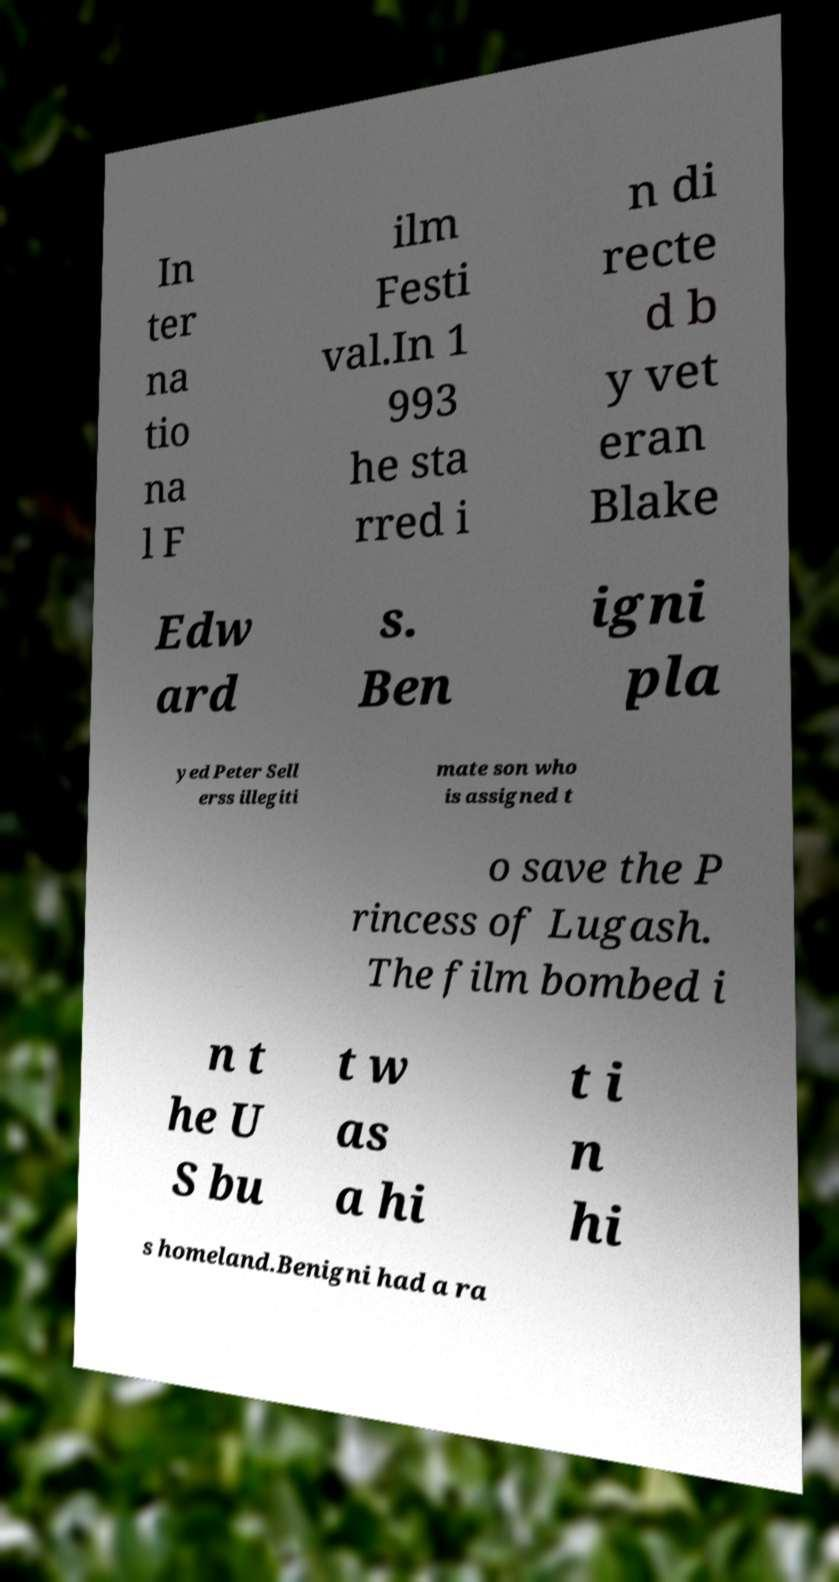I need the written content from this picture converted into text. Can you do that? In ter na tio na l F ilm Festi val.In 1 993 he sta rred i n di recte d b y vet eran Blake Edw ard s. Ben igni pla yed Peter Sell erss illegiti mate son who is assigned t o save the P rincess of Lugash. The film bombed i n t he U S bu t w as a hi t i n hi s homeland.Benigni had a ra 